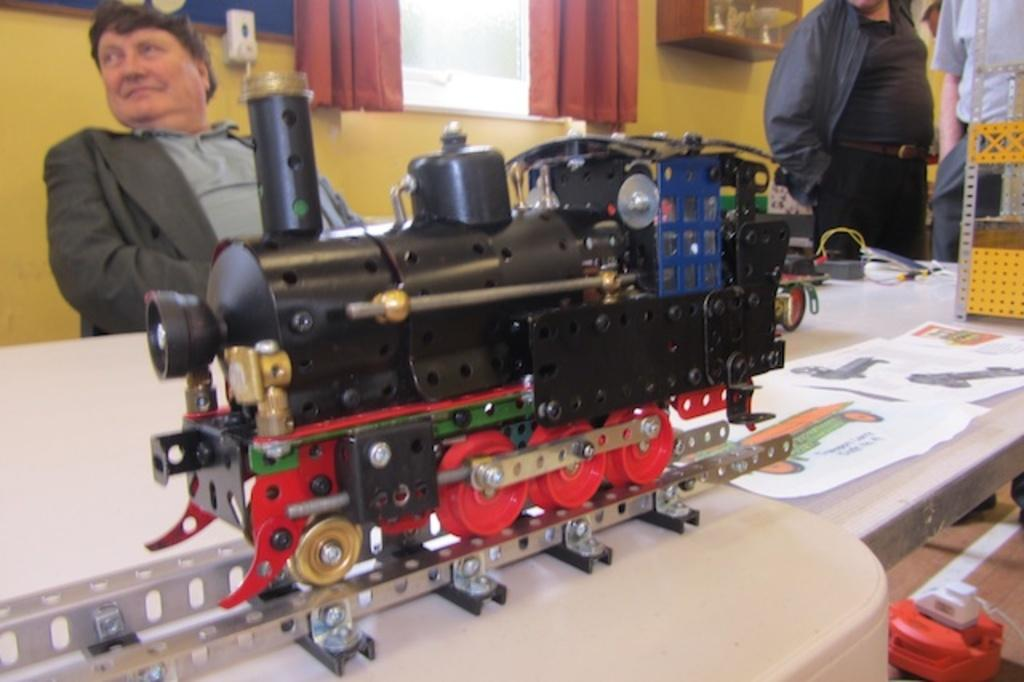What is the main subject of the image? The main subject of the image is a toy train on a railway track. Can you describe the man in the image? There is a man sitting on the left side of the image, and he is wearing a coat. What can be seen on the right side of the image? There are papers with drawings on the right side of the image. What type of bells can be heard ringing in the image? There are no bells present in the image, and therefore no sound can be heard. How many babies are visible in the image? There are no babies present in the image. 